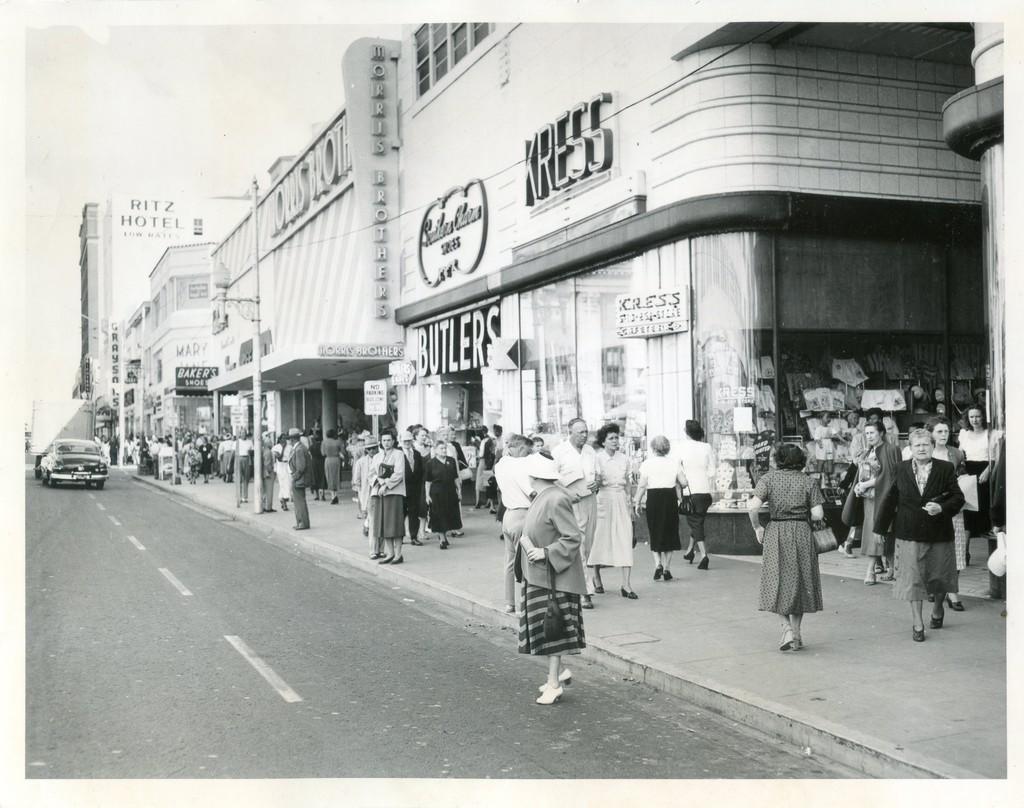Please provide a concise description of this image. This is a black and white image, there is a road ,on that road a car is moving, beside the road there is a footpath, people are walking on the foot path, beside the footpath there are some stores. 